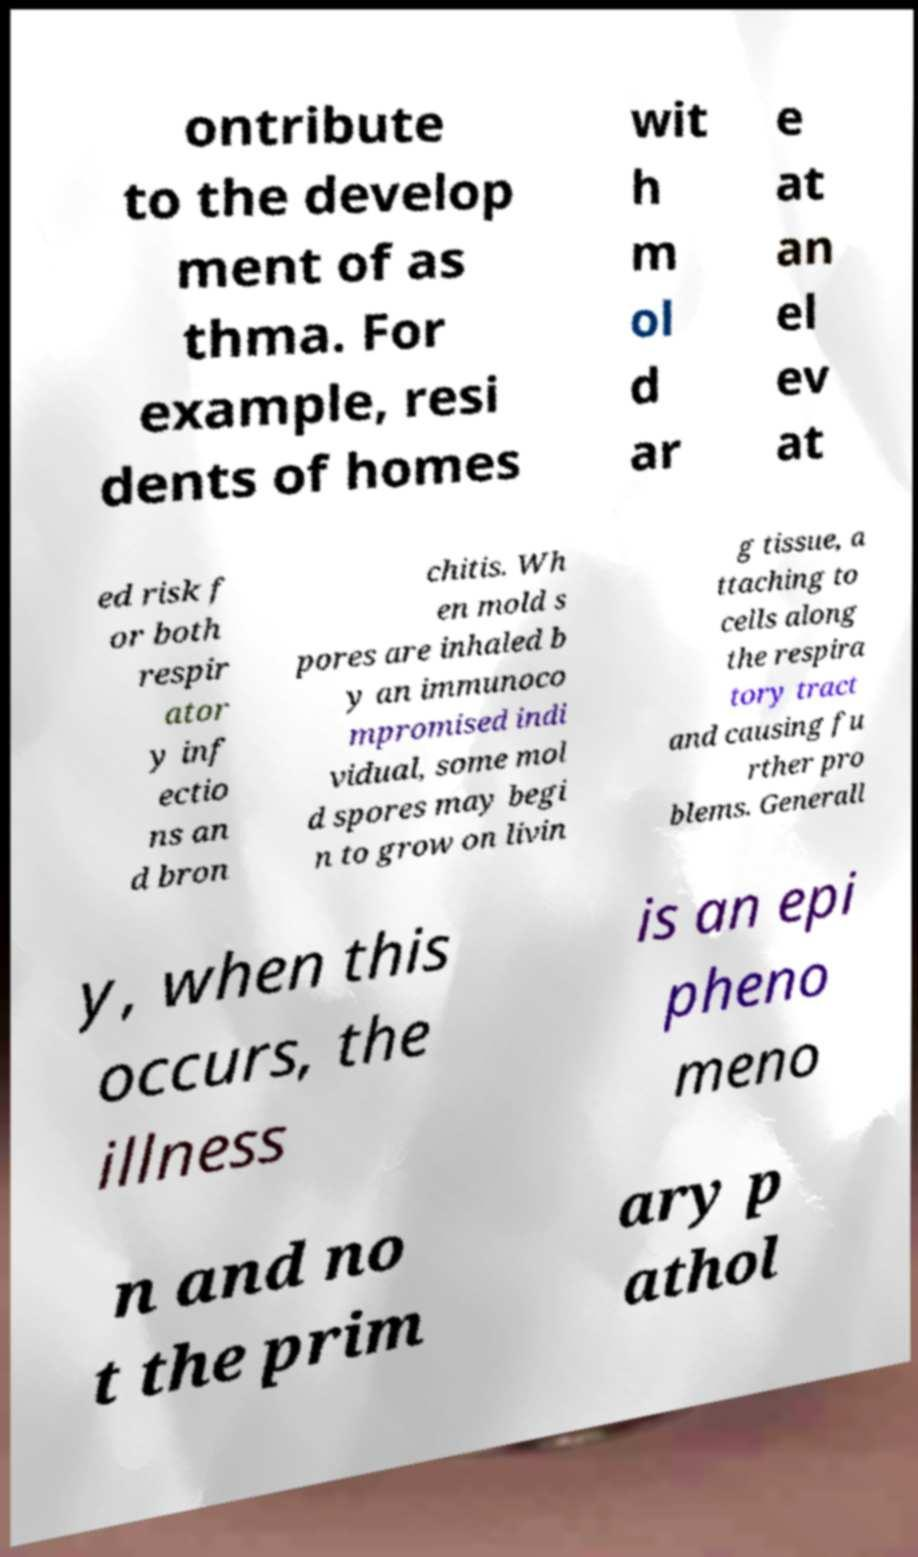Please identify and transcribe the text found in this image. ontribute to the develop ment of as thma. For example, resi dents of homes wit h m ol d ar e at an el ev at ed risk f or both respir ator y inf ectio ns an d bron chitis. Wh en mold s pores are inhaled b y an immunoco mpromised indi vidual, some mol d spores may begi n to grow on livin g tissue, a ttaching to cells along the respira tory tract and causing fu rther pro blems. Generall y, when this occurs, the illness is an epi pheno meno n and no t the prim ary p athol 